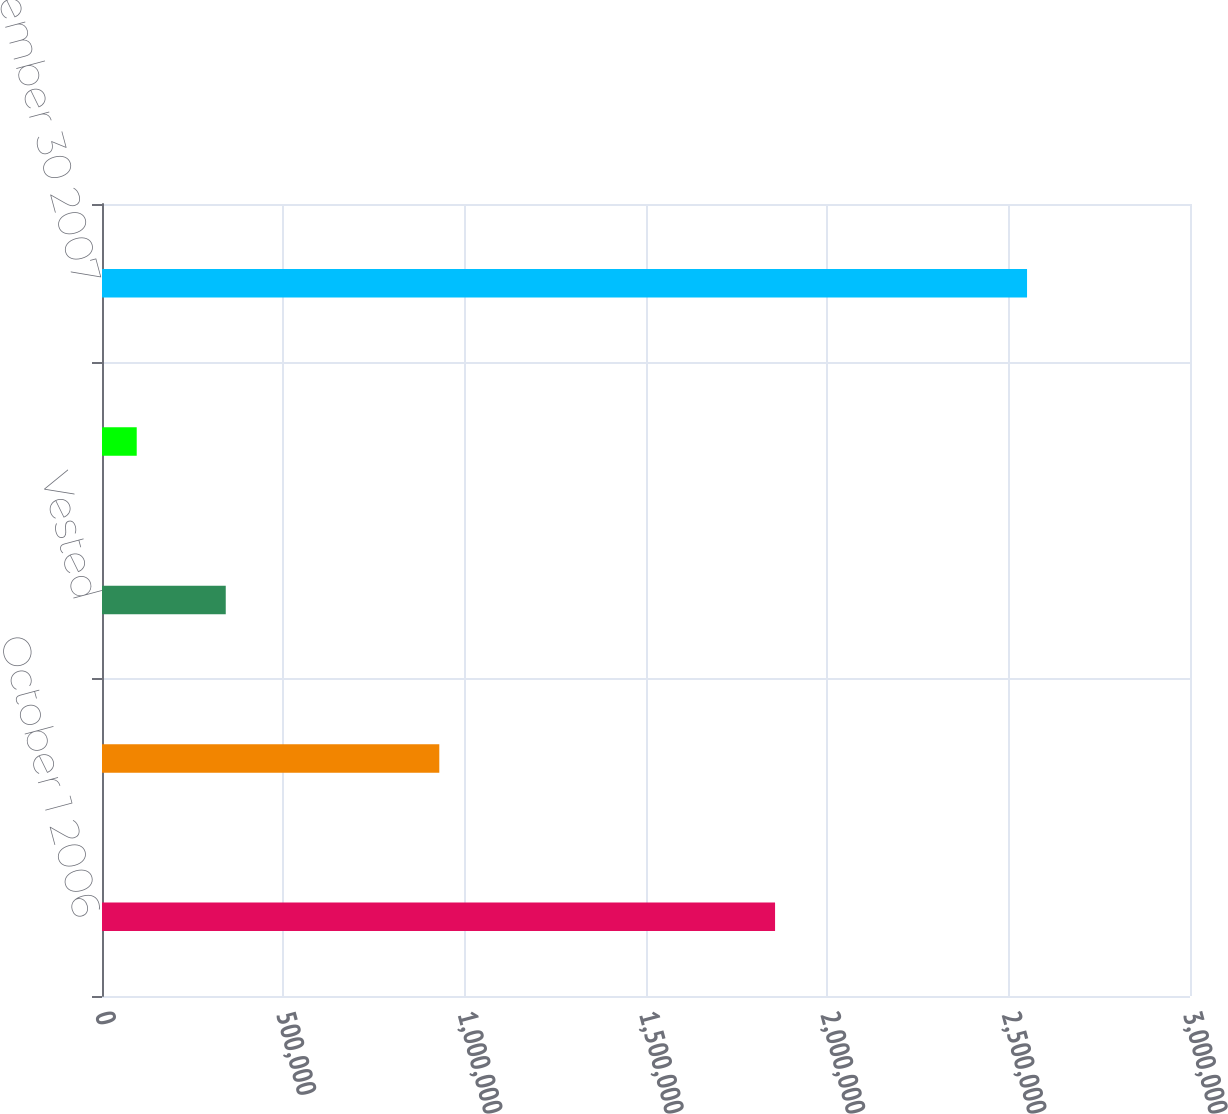Convert chart to OTSL. <chart><loc_0><loc_0><loc_500><loc_500><bar_chart><fcel>October 1 2006<fcel>Granted<fcel>Vested<fcel>Canceled<fcel>September 30 2007<nl><fcel>1.85587e+06<fcel>930060<fcel>341228<fcel>95735<fcel>2.55067e+06<nl></chart> 